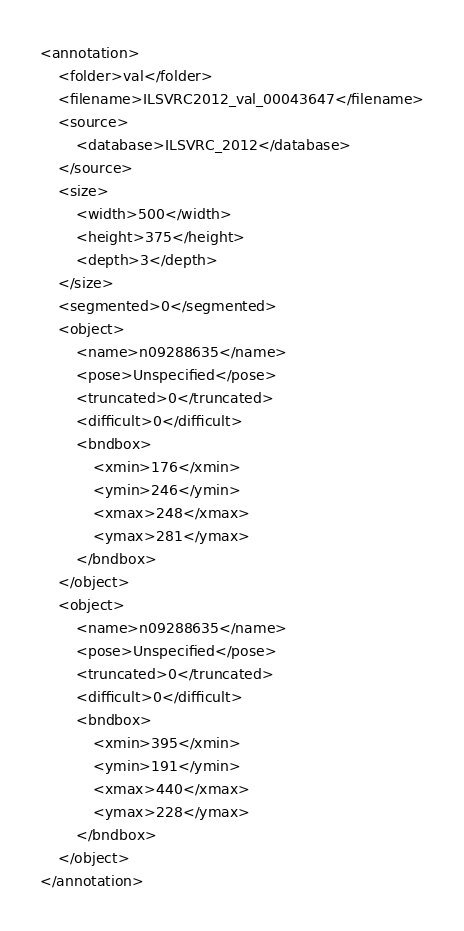Convert code to text. <code><loc_0><loc_0><loc_500><loc_500><_XML_><annotation>
	<folder>val</folder>
	<filename>ILSVRC2012_val_00043647</filename>
	<source>
		<database>ILSVRC_2012</database>
	</source>
	<size>
		<width>500</width>
		<height>375</height>
		<depth>3</depth>
	</size>
	<segmented>0</segmented>
	<object>
		<name>n09288635</name>
		<pose>Unspecified</pose>
		<truncated>0</truncated>
		<difficult>0</difficult>
		<bndbox>
			<xmin>176</xmin>
			<ymin>246</ymin>
			<xmax>248</xmax>
			<ymax>281</ymax>
		</bndbox>
	</object>
	<object>
		<name>n09288635</name>
		<pose>Unspecified</pose>
		<truncated>0</truncated>
		<difficult>0</difficult>
		<bndbox>
			<xmin>395</xmin>
			<ymin>191</ymin>
			<xmax>440</xmax>
			<ymax>228</ymax>
		</bndbox>
	</object>
</annotation></code> 